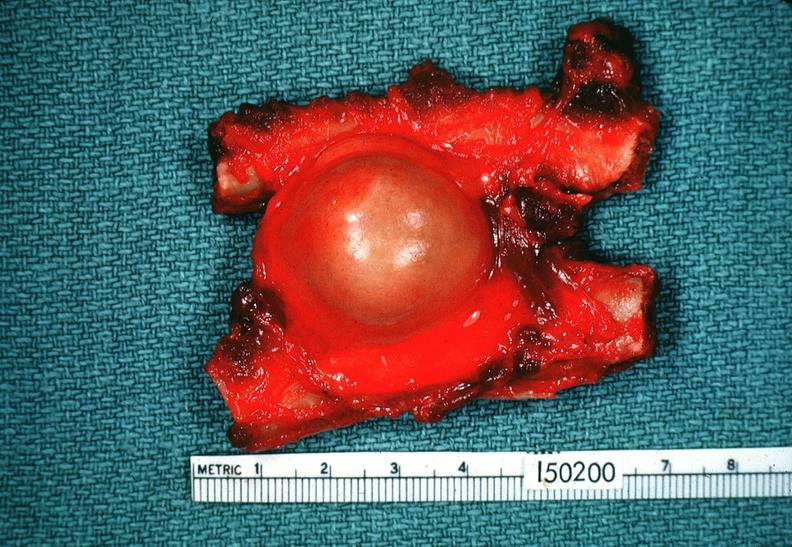does this image show schwannoma?
Answer the question using a single word or phrase. Yes 